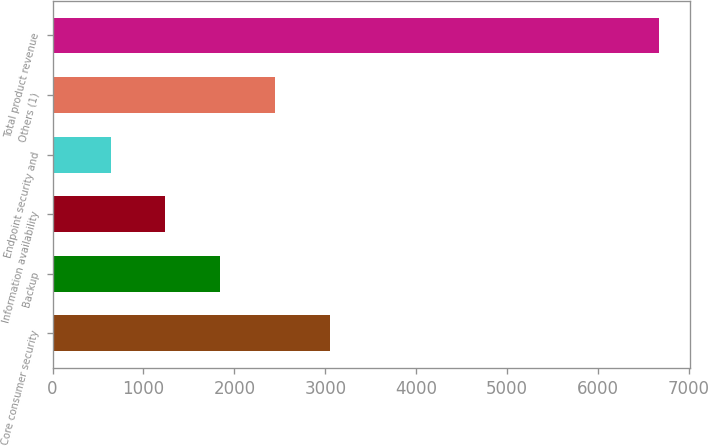Convert chart to OTSL. <chart><loc_0><loc_0><loc_500><loc_500><bar_chart><fcel>Core consumer security<fcel>Backup<fcel>Information availability<fcel>Endpoint security and<fcel>Others (1)<fcel>Total product revenue<nl><fcel>3053.2<fcel>1845.6<fcel>1241.8<fcel>638<fcel>2449.4<fcel>6676<nl></chart> 